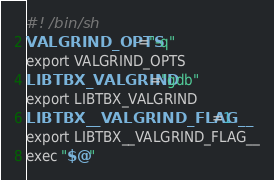<code> <loc_0><loc_0><loc_500><loc_500><_Bash_>#! /bin/sh
VALGRIND_OPTS="-q"
export VALGRIND_OPTS
LIBTBX_VALGRIND="gdb"
export LIBTBX_VALGRIND
LIBTBX__VALGRIND_FLAG__=1
export LIBTBX__VALGRIND_FLAG__
exec "$@"
</code> 